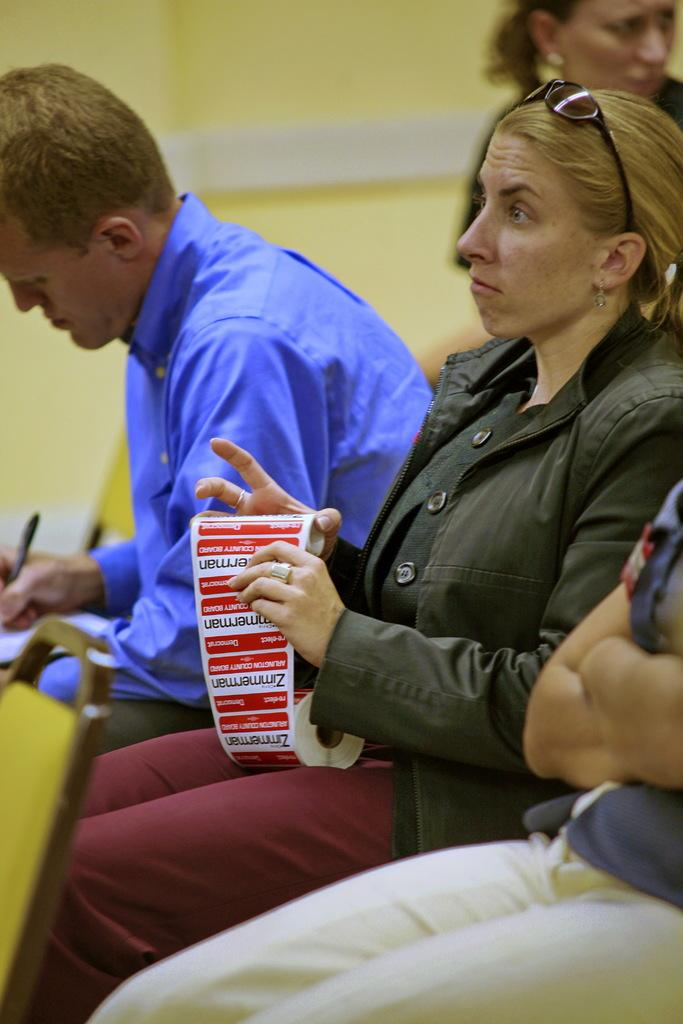What are the people in the image doing? The people in the image are sitting. What are the people wearing? The people are wearing different color dresses. What objects are the people holding? The people are holding pens and something else. What is the color of the wall in the image? The wall in the image is yellow and white in color. What type of humor can be seen in the image? There is no humor present in the image; it simply shows people sitting and holding objects. 